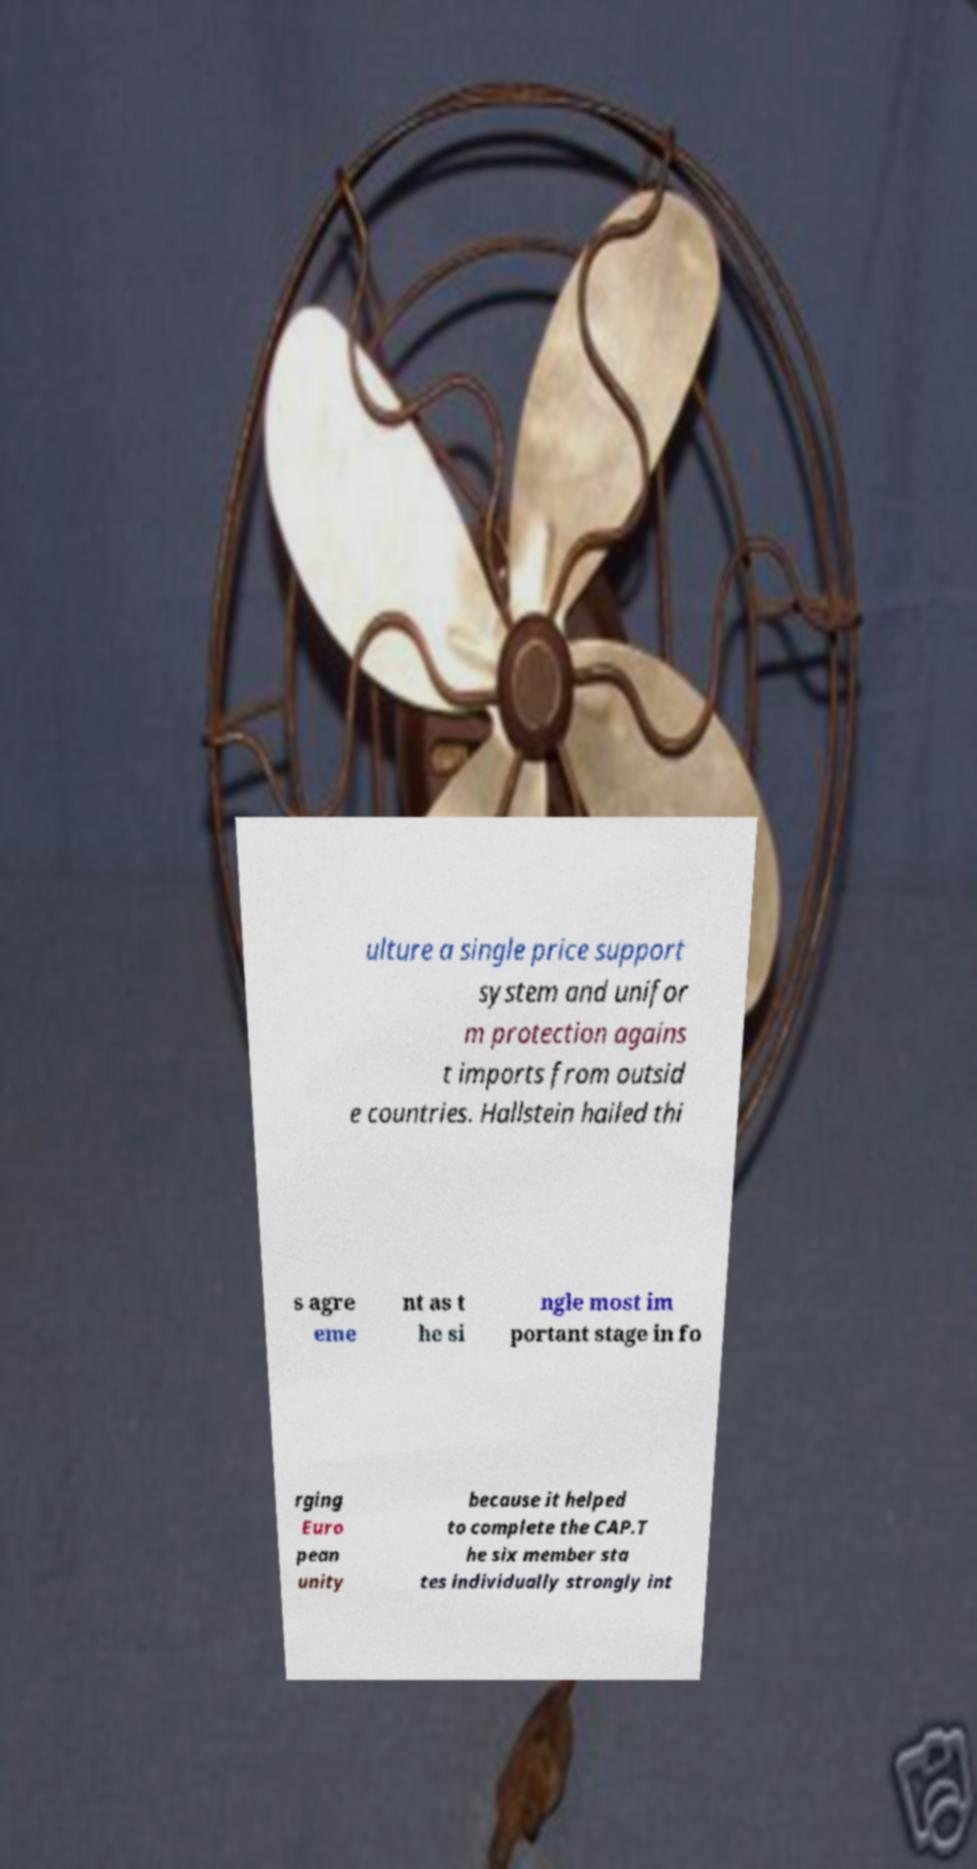Could you extract and type out the text from this image? ulture a single price support system and unifor m protection agains t imports from outsid e countries. Hallstein hailed thi s agre eme nt as t he si ngle most im portant stage in fo rging Euro pean unity because it helped to complete the CAP.T he six member sta tes individually strongly int 